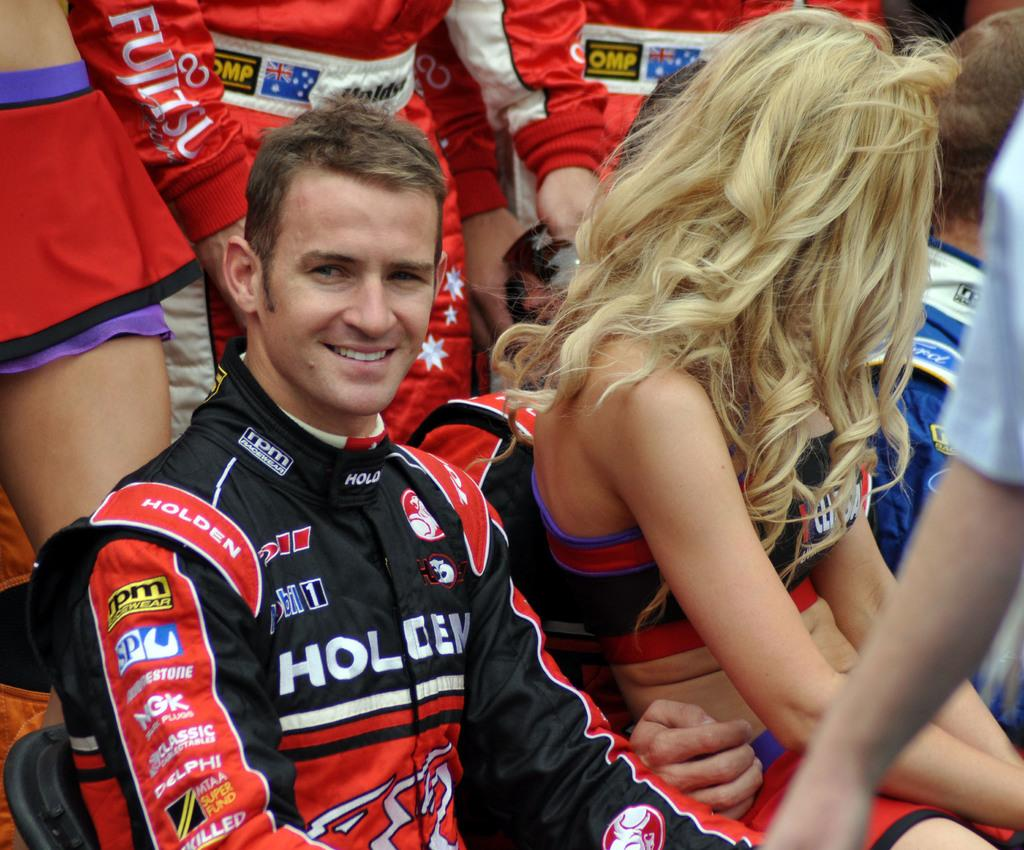<image>
Give a short and clear explanation of the subsequent image. A race car driver wears a jacket depicting the sponsor Holdem on the front. 